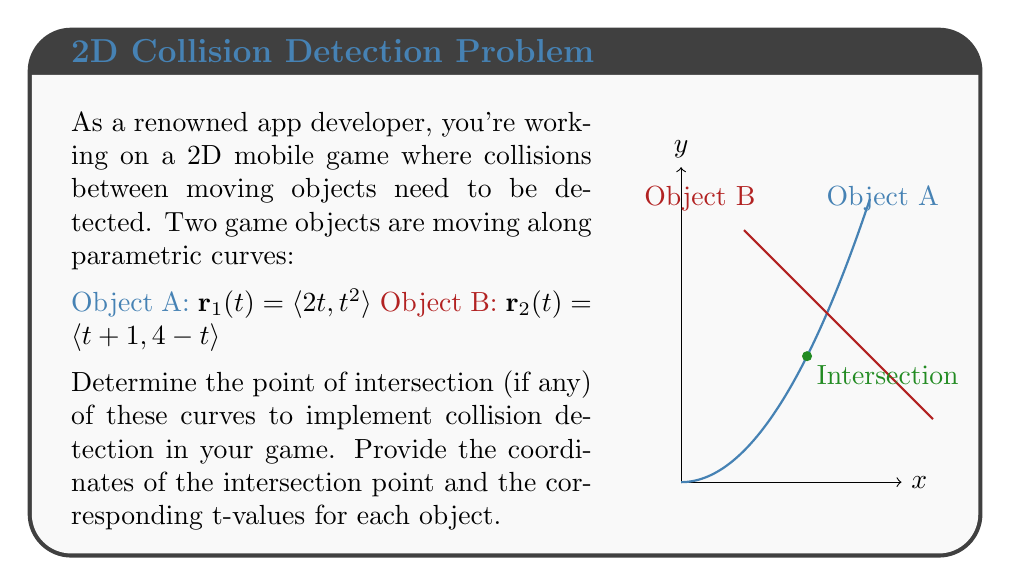Provide a solution to this math problem. To find the intersection point, we need to equate the x and y components of both parametric equations:

1) For the x-components:
   $2t_1 = t_2 + 1$, where $t_1$ is the parameter for Object A and $t_2$ is for Object B.

2) For the y-components:
   $t_1^2 = 4 - t_2$

3) From equation 1, we can express $t_2$ in terms of $t_1$:
   $t_2 = 2t_1 - 1$

4) Substitute this into equation 2:
   $t_1^2 = 4 - (2t_1 - 1)$
   $t_1^2 = 5 - 2t_1$

5) Rearrange to standard quadratic form:
   $t_1^2 + 2t_1 - 5 = 0$

6) Solve using the quadratic formula:
   $t_1 = \frac{-2 \pm \sqrt{4 + 20}}{2} = \frac{-2 \pm \sqrt{24}}{2} = \frac{-2 \pm 2\sqrt{6}}{2}$

7) The positive solution is: $t_1 = -1 + \sqrt{6} \approx 1.45$

8) Calculate $t_2$ using the equation from step 3:
   $t_2 = 2(-1 + \sqrt{6}) - 1 = -3 + 2\sqrt{6} \approx 1.90$

9) To find the intersection point, substitute $t_1$ into $\mathbf{r}_1(t)$:
   $x = 2(-1 + \sqrt{6}) = -2 + 2\sqrt{6} \approx 2.90$
   $y = (-1 + \sqrt{6})^2 = 7 - 2\sqrt{6} \approx 2.10$

Therefore, the intersection point is approximately (2.90, 2.10).
Answer: Intersection point: $(-2 + 2\sqrt{6}, 7 - 2\sqrt{6})$. $t_1 = -1 + \sqrt{6}$, $t_2 = -3 + 2\sqrt{6}$. 